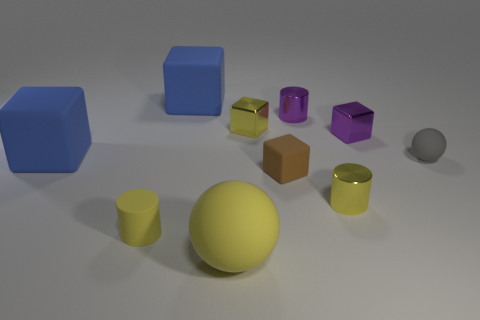There is another rubber object that is the same shape as the gray thing; what size is it?
Your answer should be very brief. Large. What shape is the yellow thing that is left of the big blue thing behind the yellow shiny block?
Give a very brief answer. Cylinder. What number of cyan things are big shiny cylinders or large objects?
Provide a short and direct response. 0. What color is the large ball?
Offer a very short reply. Yellow. Is the size of the brown object the same as the purple shiny cylinder?
Provide a short and direct response. Yes. Is there anything else that has the same shape as the small brown rubber thing?
Provide a short and direct response. Yes. Is the material of the tiny purple cube the same as the purple thing behind the small purple block?
Your answer should be very brief. Yes. Is the color of the tiny shiny block to the left of the tiny yellow metallic cylinder the same as the tiny matte sphere?
Your answer should be very brief. No. What number of rubber objects are both in front of the gray ball and to the right of the big rubber ball?
Provide a succinct answer. 1. What number of other objects are the same material as the small purple block?
Offer a very short reply. 3. 